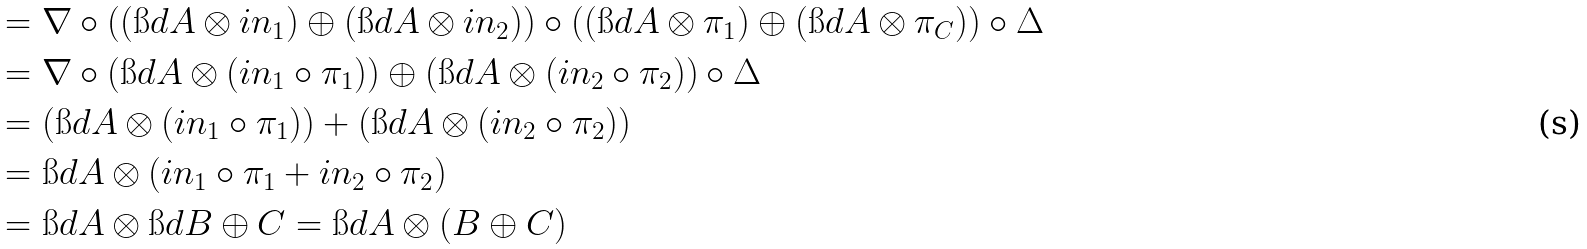Convert formula to latex. <formula><loc_0><loc_0><loc_500><loc_500>& = \nabla \circ ( ( \i d { A } \otimes i n _ { 1 } ) \oplus ( \i d { A } \otimes i n _ { 2 } ) ) \circ ( ( \i d { A } \otimes \pi _ { 1 } ) \oplus ( \i d { A } \otimes \pi _ { C } ) ) \circ \Delta \\ \quad & = \nabla \circ ( \i d { A } \otimes ( i n _ { 1 } \circ \pi _ { 1 } ) ) \oplus ( \i d { A } \otimes ( i n _ { 2 } \circ \pi _ { 2 } ) ) \circ \Delta \\ \quad & = ( \i d { A } \otimes ( i n _ { 1 } \circ \pi _ { 1 } ) ) + ( \i d { A } \otimes ( i n _ { 2 } \circ \pi _ { 2 } ) ) \\ \quad & = \i d { A } \otimes ( i n _ { 1 } \circ \pi _ { 1 } + i n _ { 2 } \circ \pi _ { 2 } ) \\ \quad & = \i d { A } \otimes \i d { B \oplus C } = \i d { A \otimes ( B \oplus C ) }</formula> 